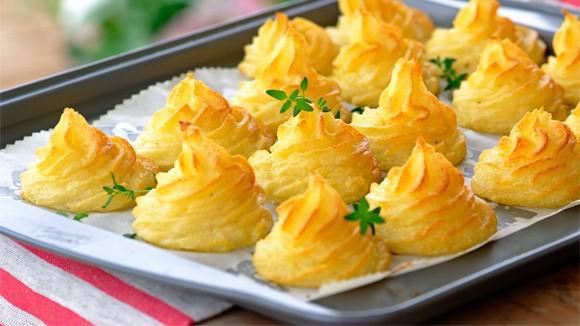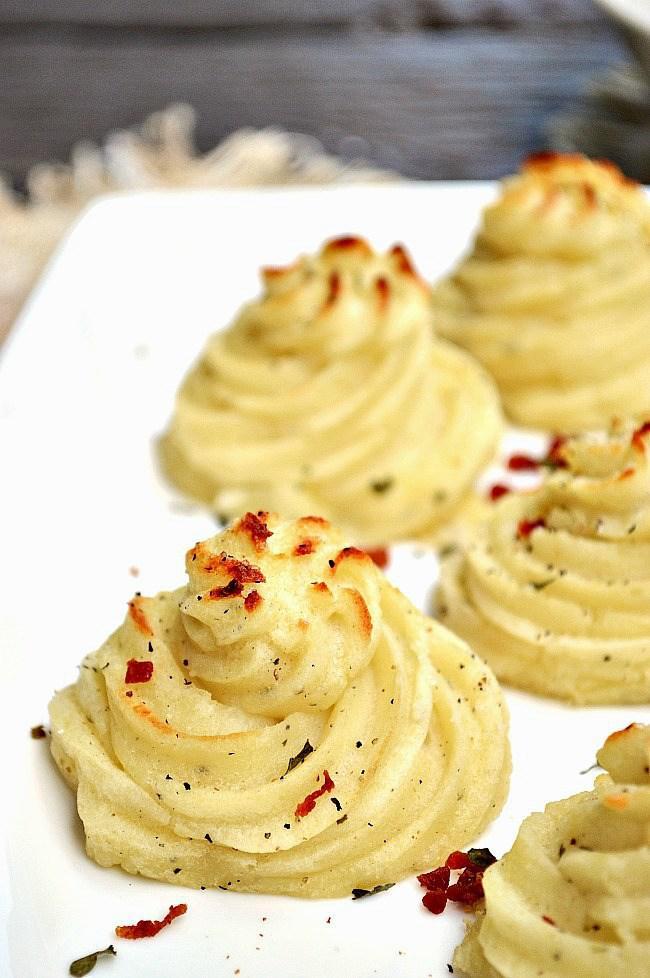The first image is the image on the left, the second image is the image on the right. Examine the images to the left and right. Is the description "The right image contains food inside of a bowl." accurate? Answer yes or no. No. 